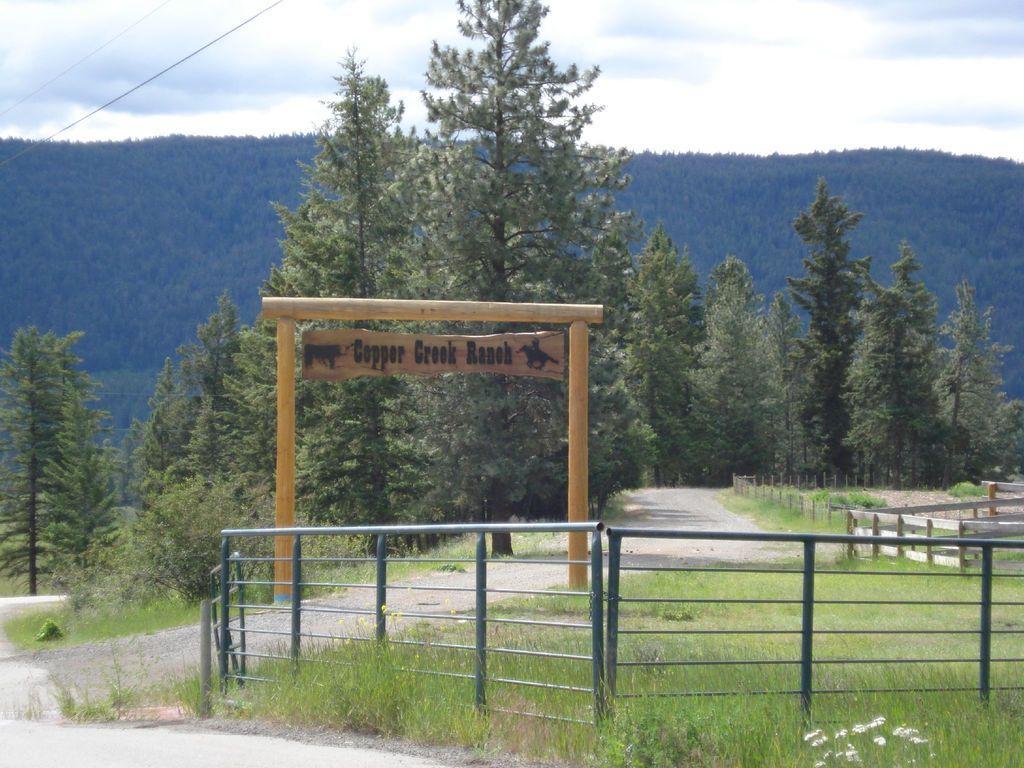How would you summarize this image in a sentence or two? In this image there is a road at the bottom. There are trees on the left corner. There is a metal railing on the right corner. There is a metal railing and a wooden object with text in the foreground. There are trees in the background. And there is sky at the top. 